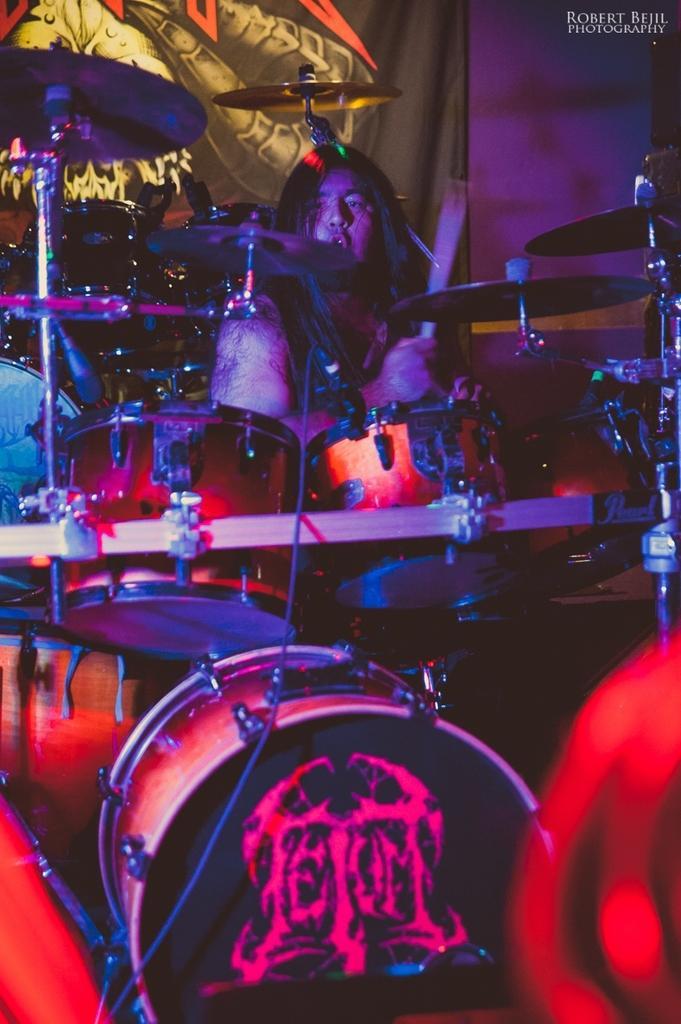Could you give a brief overview of what you see in this image? There is a band as we can see in the middle of this image. There is one person holding a stick as we can see at the top of this image. There is one curtain in the background. 